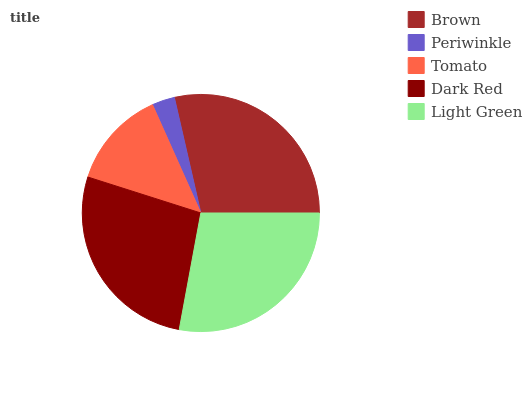Is Periwinkle the minimum?
Answer yes or no. Yes. Is Brown the maximum?
Answer yes or no. Yes. Is Tomato the minimum?
Answer yes or no. No. Is Tomato the maximum?
Answer yes or no. No. Is Tomato greater than Periwinkle?
Answer yes or no. Yes. Is Periwinkle less than Tomato?
Answer yes or no. Yes. Is Periwinkle greater than Tomato?
Answer yes or no. No. Is Tomato less than Periwinkle?
Answer yes or no. No. Is Dark Red the high median?
Answer yes or no. Yes. Is Dark Red the low median?
Answer yes or no. Yes. Is Tomato the high median?
Answer yes or no. No. Is Brown the low median?
Answer yes or no. No. 